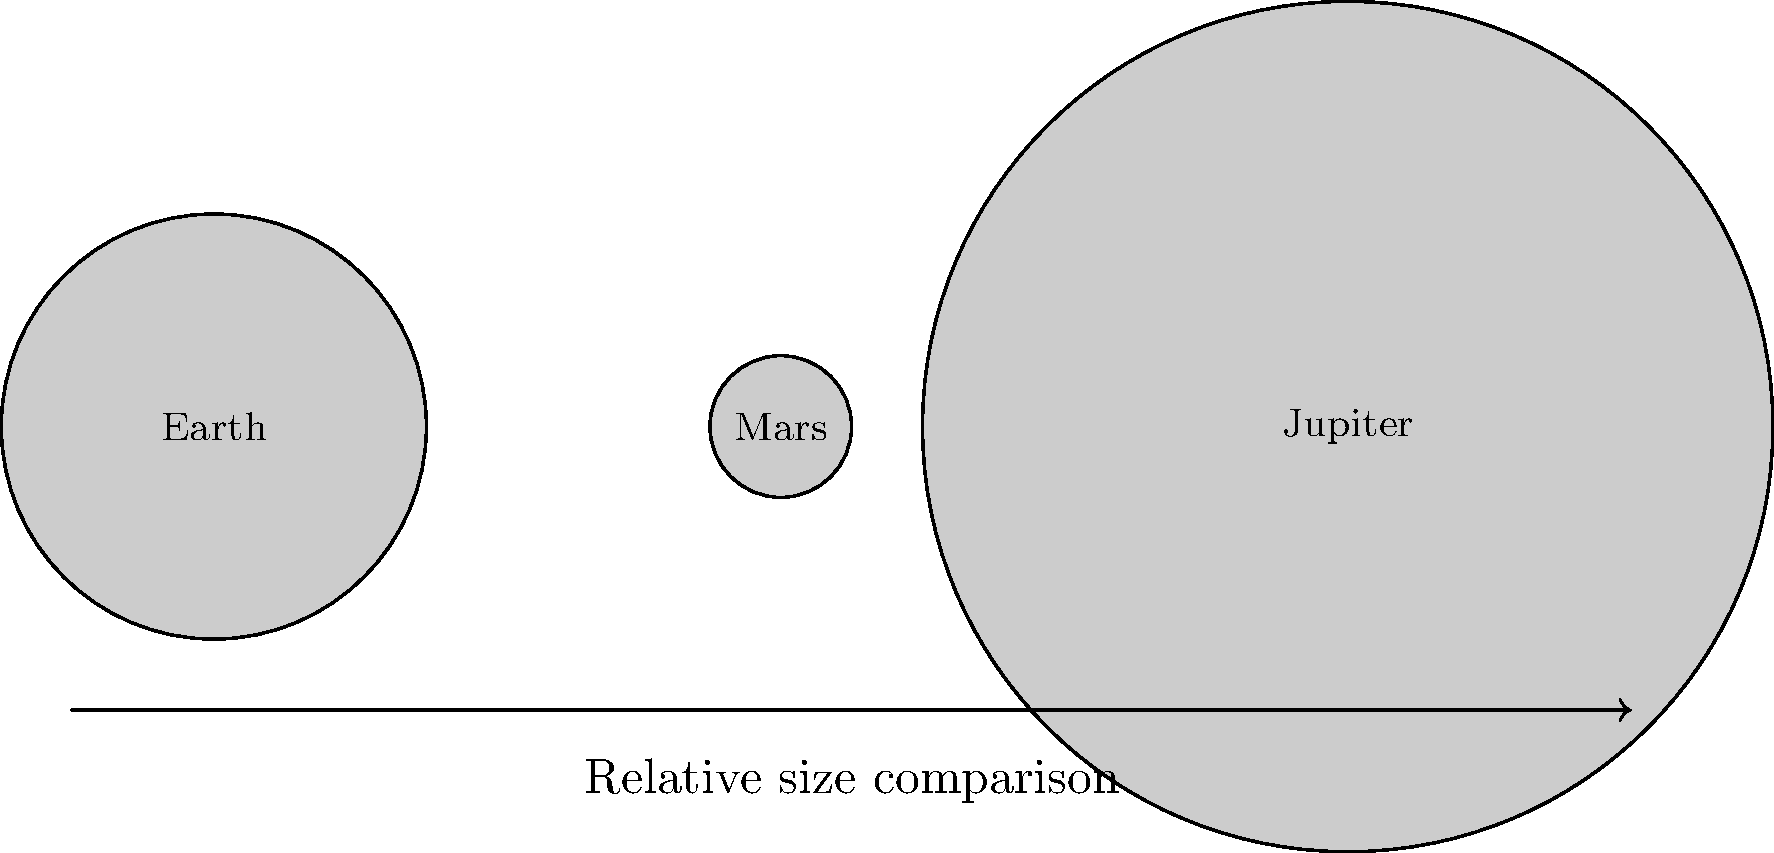In your latest historical fiction book for children about space exploration, you want to include a diagram showing the relative sizes of Earth, Mars, and Jupiter. Based on the image provided, which planet is approximately 6 times larger than Earth in diameter? To determine which planet is approximately 6 times larger than Earth in diameter, let's follow these steps:

1. Observe the relative sizes of the planets in the diagram:
   - Earth is represented by a medium-sized circle.
   - Mars is represented by the smallest circle.
   - Jupiter is represented by the largest circle.

2. Compare the diameters:
   - Mars is clearly smaller than Earth, so it's not the answer.
   - Jupiter appears to be significantly larger than Earth.

3. Estimate the ratio:
   - The diameter of Jupiter's circle is about 3 units.
   - The diameter of Earth's circle is about 0.5 units.
   - The ratio of Jupiter's diameter to Earth's is approximately 3 ÷ 0.5 = 6.

4. Verify the result:
   - Jupiter's diameter is indeed about 6 times larger than Earth's in the diagram.

In reality, Jupiter is about 11 times larger than Earth in diameter, but for the purposes of this simplified diagram and question, the representation shows Jupiter as approximately 6 times larger than Earth.
Answer: Jupiter 